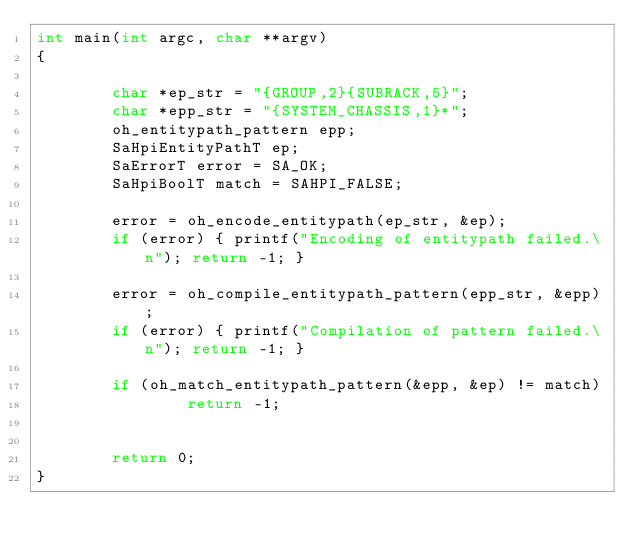<code> <loc_0><loc_0><loc_500><loc_500><_C_>int main(int argc, char **argv)
{

        char *ep_str = "{GROUP,2}{SUBRACK,5}";
        char *epp_str = "{SYSTEM_CHASSIS,1}*";
        oh_entitypath_pattern epp;
        SaHpiEntityPathT ep;
        SaErrorT error = SA_OK;
        SaHpiBoolT match = SAHPI_FALSE;

        error = oh_encode_entitypath(ep_str, &ep);
        if (error) { printf("Encoding of entitypath failed.\n"); return -1; }

        error = oh_compile_entitypath_pattern(epp_str, &epp);
        if (error) { printf("Compilation of pattern failed.\n"); return -1; }

        if (oh_match_entitypath_pattern(&epp, &ep) != match)
                return -1;
        

        return 0;
}

</code> 